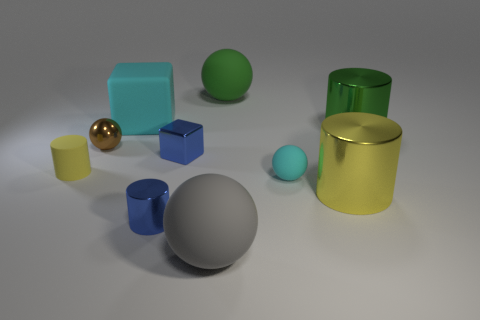Is there any other thing that is made of the same material as the tiny cyan sphere? Yes, the material of the tiny cyan sphere appears to be similar to the larger green sphere and the bluish cube to the left of the image. These items exhibit similar characteristics such as color tone and matte surface finish, suggesting they could be made of the same or similar type of plastic material. 